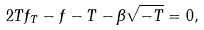<formula> <loc_0><loc_0><loc_500><loc_500>2 T f _ { T } - f - T - \beta \sqrt { - T } = 0 ,</formula> 